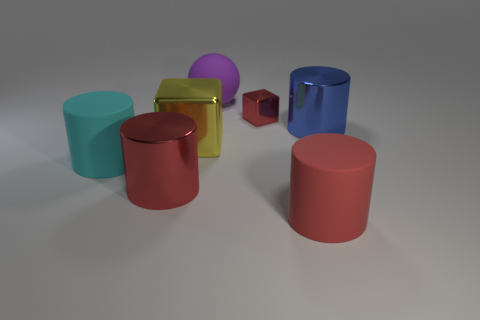Add 3 shiny blocks. How many objects exist? 10 Subtract all cylinders. How many objects are left? 3 Add 3 purple objects. How many purple objects are left? 4 Add 4 purple objects. How many purple objects exist? 5 Subtract 0 green cylinders. How many objects are left? 7 Subtract all big red metal cylinders. Subtract all yellow things. How many objects are left? 5 